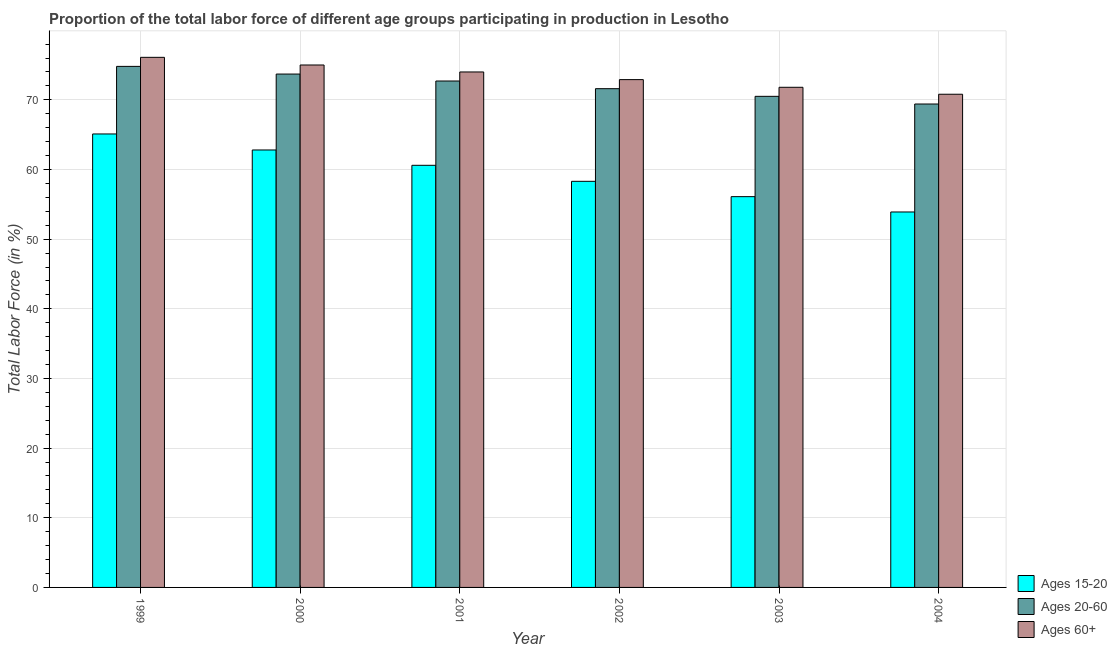How many different coloured bars are there?
Offer a terse response. 3. How many groups of bars are there?
Ensure brevity in your answer.  6. How many bars are there on the 3rd tick from the left?
Your response must be concise. 3. How many bars are there on the 2nd tick from the right?
Give a very brief answer. 3. What is the label of the 4th group of bars from the left?
Your response must be concise. 2002. In how many cases, is the number of bars for a given year not equal to the number of legend labels?
Provide a short and direct response. 0. What is the percentage of labor force within the age group 20-60 in 2000?
Provide a succinct answer. 73.7. Across all years, what is the maximum percentage of labor force within the age group 15-20?
Provide a short and direct response. 65.1. Across all years, what is the minimum percentage of labor force within the age group 15-20?
Your answer should be very brief. 53.9. In which year was the percentage of labor force within the age group 20-60 maximum?
Provide a succinct answer. 1999. What is the total percentage of labor force within the age group 15-20 in the graph?
Offer a terse response. 356.8. What is the difference between the percentage of labor force within the age group 15-20 in 2000 and that in 2003?
Give a very brief answer. 6.7. What is the difference between the percentage of labor force within the age group 20-60 in 2000 and the percentage of labor force above age 60 in 1999?
Make the answer very short. -1.1. What is the average percentage of labor force within the age group 15-20 per year?
Provide a short and direct response. 59.47. In the year 1999, what is the difference between the percentage of labor force within the age group 20-60 and percentage of labor force within the age group 15-20?
Provide a short and direct response. 0. What is the ratio of the percentage of labor force within the age group 20-60 in 2002 to that in 2003?
Give a very brief answer. 1.02. What is the difference between the highest and the second highest percentage of labor force above age 60?
Ensure brevity in your answer.  1.1. What is the difference between the highest and the lowest percentage of labor force within the age group 20-60?
Your answer should be very brief. 5.4. Is the sum of the percentage of labor force within the age group 15-20 in 2001 and 2003 greater than the maximum percentage of labor force within the age group 20-60 across all years?
Your response must be concise. Yes. What does the 1st bar from the left in 2001 represents?
Your answer should be very brief. Ages 15-20. What does the 2nd bar from the right in 2001 represents?
Provide a succinct answer. Ages 20-60. Is it the case that in every year, the sum of the percentage of labor force within the age group 15-20 and percentage of labor force within the age group 20-60 is greater than the percentage of labor force above age 60?
Your response must be concise. Yes. Are all the bars in the graph horizontal?
Your answer should be compact. No. What is the difference between two consecutive major ticks on the Y-axis?
Ensure brevity in your answer.  10. Does the graph contain any zero values?
Provide a succinct answer. No. How are the legend labels stacked?
Provide a short and direct response. Vertical. What is the title of the graph?
Offer a terse response. Proportion of the total labor force of different age groups participating in production in Lesotho. Does "Argument" appear as one of the legend labels in the graph?
Make the answer very short. No. What is the label or title of the Y-axis?
Your response must be concise. Total Labor Force (in %). What is the Total Labor Force (in %) of Ages 15-20 in 1999?
Your response must be concise. 65.1. What is the Total Labor Force (in %) of Ages 20-60 in 1999?
Make the answer very short. 74.8. What is the Total Labor Force (in %) in Ages 60+ in 1999?
Provide a short and direct response. 76.1. What is the Total Labor Force (in %) of Ages 15-20 in 2000?
Provide a succinct answer. 62.8. What is the Total Labor Force (in %) of Ages 20-60 in 2000?
Your answer should be compact. 73.7. What is the Total Labor Force (in %) of Ages 15-20 in 2001?
Give a very brief answer. 60.6. What is the Total Labor Force (in %) in Ages 20-60 in 2001?
Provide a succinct answer. 72.7. What is the Total Labor Force (in %) of Ages 60+ in 2001?
Ensure brevity in your answer.  74. What is the Total Labor Force (in %) in Ages 15-20 in 2002?
Provide a short and direct response. 58.3. What is the Total Labor Force (in %) in Ages 20-60 in 2002?
Provide a short and direct response. 71.6. What is the Total Labor Force (in %) in Ages 60+ in 2002?
Keep it short and to the point. 72.9. What is the Total Labor Force (in %) of Ages 15-20 in 2003?
Offer a very short reply. 56.1. What is the Total Labor Force (in %) of Ages 20-60 in 2003?
Your answer should be very brief. 70.5. What is the Total Labor Force (in %) of Ages 60+ in 2003?
Make the answer very short. 71.8. What is the Total Labor Force (in %) in Ages 15-20 in 2004?
Your response must be concise. 53.9. What is the Total Labor Force (in %) in Ages 20-60 in 2004?
Your answer should be very brief. 69.4. What is the Total Labor Force (in %) in Ages 60+ in 2004?
Offer a terse response. 70.8. Across all years, what is the maximum Total Labor Force (in %) of Ages 15-20?
Your response must be concise. 65.1. Across all years, what is the maximum Total Labor Force (in %) in Ages 20-60?
Ensure brevity in your answer.  74.8. Across all years, what is the maximum Total Labor Force (in %) in Ages 60+?
Your answer should be very brief. 76.1. Across all years, what is the minimum Total Labor Force (in %) of Ages 15-20?
Your answer should be very brief. 53.9. Across all years, what is the minimum Total Labor Force (in %) of Ages 20-60?
Give a very brief answer. 69.4. Across all years, what is the minimum Total Labor Force (in %) of Ages 60+?
Keep it short and to the point. 70.8. What is the total Total Labor Force (in %) in Ages 15-20 in the graph?
Provide a short and direct response. 356.8. What is the total Total Labor Force (in %) in Ages 20-60 in the graph?
Your answer should be very brief. 432.7. What is the total Total Labor Force (in %) in Ages 60+ in the graph?
Provide a short and direct response. 440.6. What is the difference between the Total Labor Force (in %) in Ages 60+ in 1999 and that in 2000?
Provide a succinct answer. 1.1. What is the difference between the Total Labor Force (in %) in Ages 15-20 in 1999 and that in 2001?
Your answer should be very brief. 4.5. What is the difference between the Total Labor Force (in %) in Ages 60+ in 1999 and that in 2001?
Make the answer very short. 2.1. What is the difference between the Total Labor Force (in %) of Ages 20-60 in 1999 and that in 2002?
Your response must be concise. 3.2. What is the difference between the Total Labor Force (in %) of Ages 20-60 in 1999 and that in 2003?
Make the answer very short. 4.3. What is the difference between the Total Labor Force (in %) in Ages 15-20 in 1999 and that in 2004?
Your answer should be very brief. 11.2. What is the difference between the Total Labor Force (in %) in Ages 20-60 in 2000 and that in 2001?
Provide a succinct answer. 1. What is the difference between the Total Labor Force (in %) in Ages 60+ in 2000 and that in 2001?
Offer a terse response. 1. What is the difference between the Total Labor Force (in %) of Ages 15-20 in 2000 and that in 2002?
Provide a succinct answer. 4.5. What is the difference between the Total Labor Force (in %) in Ages 20-60 in 2000 and that in 2002?
Your answer should be compact. 2.1. What is the difference between the Total Labor Force (in %) of Ages 15-20 in 2000 and that in 2003?
Offer a very short reply. 6.7. What is the difference between the Total Labor Force (in %) in Ages 20-60 in 2000 and that in 2003?
Ensure brevity in your answer.  3.2. What is the difference between the Total Labor Force (in %) in Ages 60+ in 2000 and that in 2004?
Offer a very short reply. 4.2. What is the difference between the Total Labor Force (in %) of Ages 15-20 in 2001 and that in 2002?
Provide a short and direct response. 2.3. What is the difference between the Total Labor Force (in %) in Ages 60+ in 2001 and that in 2002?
Offer a terse response. 1.1. What is the difference between the Total Labor Force (in %) of Ages 15-20 in 2001 and that in 2003?
Ensure brevity in your answer.  4.5. What is the difference between the Total Labor Force (in %) in Ages 20-60 in 2001 and that in 2003?
Provide a short and direct response. 2.2. What is the difference between the Total Labor Force (in %) of Ages 60+ in 2001 and that in 2003?
Your answer should be compact. 2.2. What is the difference between the Total Labor Force (in %) in Ages 15-20 in 2001 and that in 2004?
Ensure brevity in your answer.  6.7. What is the difference between the Total Labor Force (in %) of Ages 60+ in 2001 and that in 2004?
Provide a succinct answer. 3.2. What is the difference between the Total Labor Force (in %) in Ages 15-20 in 2002 and that in 2003?
Give a very brief answer. 2.2. What is the difference between the Total Labor Force (in %) in Ages 60+ in 2002 and that in 2003?
Give a very brief answer. 1.1. What is the difference between the Total Labor Force (in %) of Ages 20-60 in 2002 and that in 2004?
Your answer should be very brief. 2.2. What is the difference between the Total Labor Force (in %) of Ages 15-20 in 2003 and that in 2004?
Provide a succinct answer. 2.2. What is the difference between the Total Labor Force (in %) in Ages 20-60 in 2003 and that in 2004?
Give a very brief answer. 1.1. What is the difference between the Total Labor Force (in %) in Ages 20-60 in 1999 and the Total Labor Force (in %) in Ages 60+ in 2001?
Ensure brevity in your answer.  0.8. What is the difference between the Total Labor Force (in %) of Ages 20-60 in 1999 and the Total Labor Force (in %) of Ages 60+ in 2002?
Offer a terse response. 1.9. What is the difference between the Total Labor Force (in %) in Ages 20-60 in 1999 and the Total Labor Force (in %) in Ages 60+ in 2003?
Your response must be concise. 3. What is the difference between the Total Labor Force (in %) in Ages 15-20 in 1999 and the Total Labor Force (in %) in Ages 60+ in 2004?
Offer a terse response. -5.7. What is the difference between the Total Labor Force (in %) of Ages 15-20 in 2000 and the Total Labor Force (in %) of Ages 20-60 in 2001?
Provide a short and direct response. -9.9. What is the difference between the Total Labor Force (in %) in Ages 15-20 in 2000 and the Total Labor Force (in %) in Ages 20-60 in 2002?
Your response must be concise. -8.8. What is the difference between the Total Labor Force (in %) of Ages 20-60 in 2000 and the Total Labor Force (in %) of Ages 60+ in 2002?
Your answer should be compact. 0.8. What is the difference between the Total Labor Force (in %) in Ages 15-20 in 2000 and the Total Labor Force (in %) in Ages 20-60 in 2003?
Give a very brief answer. -7.7. What is the difference between the Total Labor Force (in %) in Ages 20-60 in 2000 and the Total Labor Force (in %) in Ages 60+ in 2004?
Offer a terse response. 2.9. What is the difference between the Total Labor Force (in %) in Ages 15-20 in 2001 and the Total Labor Force (in %) in Ages 20-60 in 2003?
Ensure brevity in your answer.  -9.9. What is the difference between the Total Labor Force (in %) in Ages 15-20 in 2001 and the Total Labor Force (in %) in Ages 60+ in 2003?
Provide a succinct answer. -11.2. What is the difference between the Total Labor Force (in %) of Ages 15-20 in 2001 and the Total Labor Force (in %) of Ages 60+ in 2004?
Your response must be concise. -10.2. What is the difference between the Total Labor Force (in %) of Ages 20-60 in 2001 and the Total Labor Force (in %) of Ages 60+ in 2004?
Keep it short and to the point. 1.9. What is the difference between the Total Labor Force (in %) of Ages 15-20 in 2002 and the Total Labor Force (in %) of Ages 20-60 in 2003?
Provide a short and direct response. -12.2. What is the difference between the Total Labor Force (in %) of Ages 15-20 in 2002 and the Total Labor Force (in %) of Ages 60+ in 2003?
Ensure brevity in your answer.  -13.5. What is the difference between the Total Labor Force (in %) of Ages 20-60 in 2002 and the Total Labor Force (in %) of Ages 60+ in 2003?
Provide a succinct answer. -0.2. What is the difference between the Total Labor Force (in %) of Ages 20-60 in 2002 and the Total Labor Force (in %) of Ages 60+ in 2004?
Keep it short and to the point. 0.8. What is the difference between the Total Labor Force (in %) in Ages 15-20 in 2003 and the Total Labor Force (in %) in Ages 20-60 in 2004?
Offer a terse response. -13.3. What is the difference between the Total Labor Force (in %) in Ages 15-20 in 2003 and the Total Labor Force (in %) in Ages 60+ in 2004?
Your answer should be compact. -14.7. What is the average Total Labor Force (in %) in Ages 15-20 per year?
Ensure brevity in your answer.  59.47. What is the average Total Labor Force (in %) in Ages 20-60 per year?
Make the answer very short. 72.12. What is the average Total Labor Force (in %) of Ages 60+ per year?
Your answer should be compact. 73.43. In the year 1999, what is the difference between the Total Labor Force (in %) of Ages 15-20 and Total Labor Force (in %) of Ages 20-60?
Keep it short and to the point. -9.7. In the year 1999, what is the difference between the Total Labor Force (in %) in Ages 15-20 and Total Labor Force (in %) in Ages 60+?
Your response must be concise. -11. In the year 2000, what is the difference between the Total Labor Force (in %) in Ages 15-20 and Total Labor Force (in %) in Ages 20-60?
Ensure brevity in your answer.  -10.9. In the year 2000, what is the difference between the Total Labor Force (in %) of Ages 15-20 and Total Labor Force (in %) of Ages 60+?
Provide a succinct answer. -12.2. In the year 2001, what is the difference between the Total Labor Force (in %) of Ages 15-20 and Total Labor Force (in %) of Ages 60+?
Offer a very short reply. -13.4. In the year 2001, what is the difference between the Total Labor Force (in %) in Ages 20-60 and Total Labor Force (in %) in Ages 60+?
Make the answer very short. -1.3. In the year 2002, what is the difference between the Total Labor Force (in %) in Ages 15-20 and Total Labor Force (in %) in Ages 60+?
Ensure brevity in your answer.  -14.6. In the year 2003, what is the difference between the Total Labor Force (in %) of Ages 15-20 and Total Labor Force (in %) of Ages 20-60?
Make the answer very short. -14.4. In the year 2003, what is the difference between the Total Labor Force (in %) in Ages 15-20 and Total Labor Force (in %) in Ages 60+?
Keep it short and to the point. -15.7. In the year 2004, what is the difference between the Total Labor Force (in %) in Ages 15-20 and Total Labor Force (in %) in Ages 20-60?
Ensure brevity in your answer.  -15.5. In the year 2004, what is the difference between the Total Labor Force (in %) in Ages 15-20 and Total Labor Force (in %) in Ages 60+?
Give a very brief answer. -16.9. In the year 2004, what is the difference between the Total Labor Force (in %) in Ages 20-60 and Total Labor Force (in %) in Ages 60+?
Provide a short and direct response. -1.4. What is the ratio of the Total Labor Force (in %) in Ages 15-20 in 1999 to that in 2000?
Make the answer very short. 1.04. What is the ratio of the Total Labor Force (in %) in Ages 20-60 in 1999 to that in 2000?
Keep it short and to the point. 1.01. What is the ratio of the Total Labor Force (in %) of Ages 60+ in 1999 to that in 2000?
Your answer should be very brief. 1.01. What is the ratio of the Total Labor Force (in %) of Ages 15-20 in 1999 to that in 2001?
Offer a terse response. 1.07. What is the ratio of the Total Labor Force (in %) of Ages 20-60 in 1999 to that in 2001?
Make the answer very short. 1.03. What is the ratio of the Total Labor Force (in %) of Ages 60+ in 1999 to that in 2001?
Provide a succinct answer. 1.03. What is the ratio of the Total Labor Force (in %) of Ages 15-20 in 1999 to that in 2002?
Offer a terse response. 1.12. What is the ratio of the Total Labor Force (in %) in Ages 20-60 in 1999 to that in 2002?
Offer a terse response. 1.04. What is the ratio of the Total Labor Force (in %) in Ages 60+ in 1999 to that in 2002?
Make the answer very short. 1.04. What is the ratio of the Total Labor Force (in %) in Ages 15-20 in 1999 to that in 2003?
Give a very brief answer. 1.16. What is the ratio of the Total Labor Force (in %) in Ages 20-60 in 1999 to that in 2003?
Your answer should be compact. 1.06. What is the ratio of the Total Labor Force (in %) of Ages 60+ in 1999 to that in 2003?
Give a very brief answer. 1.06. What is the ratio of the Total Labor Force (in %) of Ages 15-20 in 1999 to that in 2004?
Make the answer very short. 1.21. What is the ratio of the Total Labor Force (in %) of Ages 20-60 in 1999 to that in 2004?
Offer a terse response. 1.08. What is the ratio of the Total Labor Force (in %) in Ages 60+ in 1999 to that in 2004?
Make the answer very short. 1.07. What is the ratio of the Total Labor Force (in %) of Ages 15-20 in 2000 to that in 2001?
Make the answer very short. 1.04. What is the ratio of the Total Labor Force (in %) in Ages 20-60 in 2000 to that in 2001?
Keep it short and to the point. 1.01. What is the ratio of the Total Labor Force (in %) in Ages 60+ in 2000 to that in 2001?
Keep it short and to the point. 1.01. What is the ratio of the Total Labor Force (in %) in Ages 15-20 in 2000 to that in 2002?
Provide a short and direct response. 1.08. What is the ratio of the Total Labor Force (in %) of Ages 20-60 in 2000 to that in 2002?
Offer a terse response. 1.03. What is the ratio of the Total Labor Force (in %) of Ages 60+ in 2000 to that in 2002?
Give a very brief answer. 1.03. What is the ratio of the Total Labor Force (in %) in Ages 15-20 in 2000 to that in 2003?
Your response must be concise. 1.12. What is the ratio of the Total Labor Force (in %) of Ages 20-60 in 2000 to that in 2003?
Your answer should be compact. 1.05. What is the ratio of the Total Labor Force (in %) of Ages 60+ in 2000 to that in 2003?
Provide a short and direct response. 1.04. What is the ratio of the Total Labor Force (in %) in Ages 15-20 in 2000 to that in 2004?
Keep it short and to the point. 1.17. What is the ratio of the Total Labor Force (in %) in Ages 20-60 in 2000 to that in 2004?
Provide a short and direct response. 1.06. What is the ratio of the Total Labor Force (in %) in Ages 60+ in 2000 to that in 2004?
Give a very brief answer. 1.06. What is the ratio of the Total Labor Force (in %) of Ages 15-20 in 2001 to that in 2002?
Provide a succinct answer. 1.04. What is the ratio of the Total Labor Force (in %) in Ages 20-60 in 2001 to that in 2002?
Give a very brief answer. 1.02. What is the ratio of the Total Labor Force (in %) of Ages 60+ in 2001 to that in 2002?
Offer a terse response. 1.02. What is the ratio of the Total Labor Force (in %) in Ages 15-20 in 2001 to that in 2003?
Your answer should be very brief. 1.08. What is the ratio of the Total Labor Force (in %) of Ages 20-60 in 2001 to that in 2003?
Ensure brevity in your answer.  1.03. What is the ratio of the Total Labor Force (in %) of Ages 60+ in 2001 to that in 2003?
Keep it short and to the point. 1.03. What is the ratio of the Total Labor Force (in %) of Ages 15-20 in 2001 to that in 2004?
Keep it short and to the point. 1.12. What is the ratio of the Total Labor Force (in %) in Ages 20-60 in 2001 to that in 2004?
Offer a terse response. 1.05. What is the ratio of the Total Labor Force (in %) in Ages 60+ in 2001 to that in 2004?
Provide a succinct answer. 1.05. What is the ratio of the Total Labor Force (in %) in Ages 15-20 in 2002 to that in 2003?
Provide a short and direct response. 1.04. What is the ratio of the Total Labor Force (in %) in Ages 20-60 in 2002 to that in 2003?
Give a very brief answer. 1.02. What is the ratio of the Total Labor Force (in %) in Ages 60+ in 2002 to that in 2003?
Your response must be concise. 1.02. What is the ratio of the Total Labor Force (in %) in Ages 15-20 in 2002 to that in 2004?
Your answer should be very brief. 1.08. What is the ratio of the Total Labor Force (in %) of Ages 20-60 in 2002 to that in 2004?
Keep it short and to the point. 1.03. What is the ratio of the Total Labor Force (in %) in Ages 60+ in 2002 to that in 2004?
Ensure brevity in your answer.  1.03. What is the ratio of the Total Labor Force (in %) in Ages 15-20 in 2003 to that in 2004?
Give a very brief answer. 1.04. What is the ratio of the Total Labor Force (in %) of Ages 20-60 in 2003 to that in 2004?
Keep it short and to the point. 1.02. What is the ratio of the Total Labor Force (in %) of Ages 60+ in 2003 to that in 2004?
Offer a terse response. 1.01. What is the difference between the highest and the second highest Total Labor Force (in %) in Ages 15-20?
Your answer should be very brief. 2.3. What is the difference between the highest and the lowest Total Labor Force (in %) of Ages 15-20?
Your answer should be compact. 11.2. What is the difference between the highest and the lowest Total Labor Force (in %) of Ages 60+?
Offer a very short reply. 5.3. 